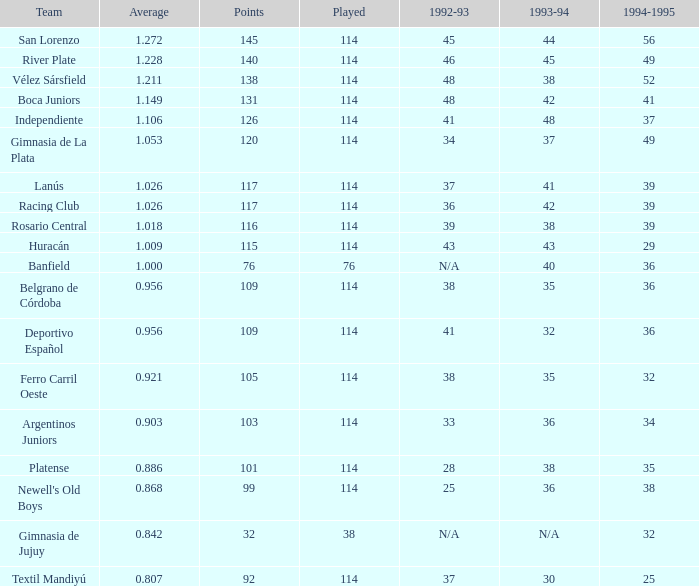Name the total number of 1992-93 for 115 points 1.0. 